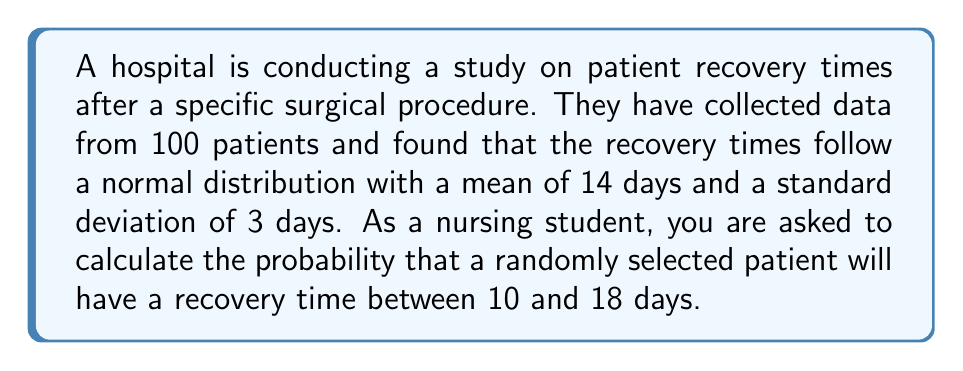Give your solution to this math problem. To solve this problem, we need to use the properties of the normal distribution and the concept of z-scores. Here's a step-by-step explanation:

1. We are given that the recovery times follow a normal distribution with:
   Mean (μ) = 14 days
   Standard deviation (σ) = 3 days

2. We need to find the probability of a recovery time between 10 and 18 days.

3. To use the standard normal distribution table, we need to convert these values to z-scores:

   For 10 days: $z_1 = \frac{x_1 - \mu}{\sigma} = \frac{10 - 14}{3} = -\frac{4}{3} \approx -1.33$

   For 18 days: $z_2 = \frac{x_2 - \mu}{\sigma} = \frac{18 - 14}{3} = \frac{4}{3} \approx 1.33$

4. Now, we need to find the area under the standard normal curve between z = -1.33 and z = 1.33.

5. Using a standard normal distribution table or calculator:
   P(z ≤ 1.33) ≈ 0.9082
   P(z ≤ -1.33) ≈ 0.0918

6. The probability we're looking for is the difference between these two values:
   P(-1.33 ≤ z ≤ 1.33) = P(z ≤ 1.33) - P(z ≤ -1.33)
                        ≈ 0.9082 - 0.0918
                        ≈ 0.8164

7. Therefore, the probability that a randomly selected patient will have a recovery time between 10 and 18 days is approximately 0.8164 or 81.64%.
Answer: The probability that a randomly selected patient will have a recovery time between 10 and 18 days is approximately 0.8164 or 81.64%. 